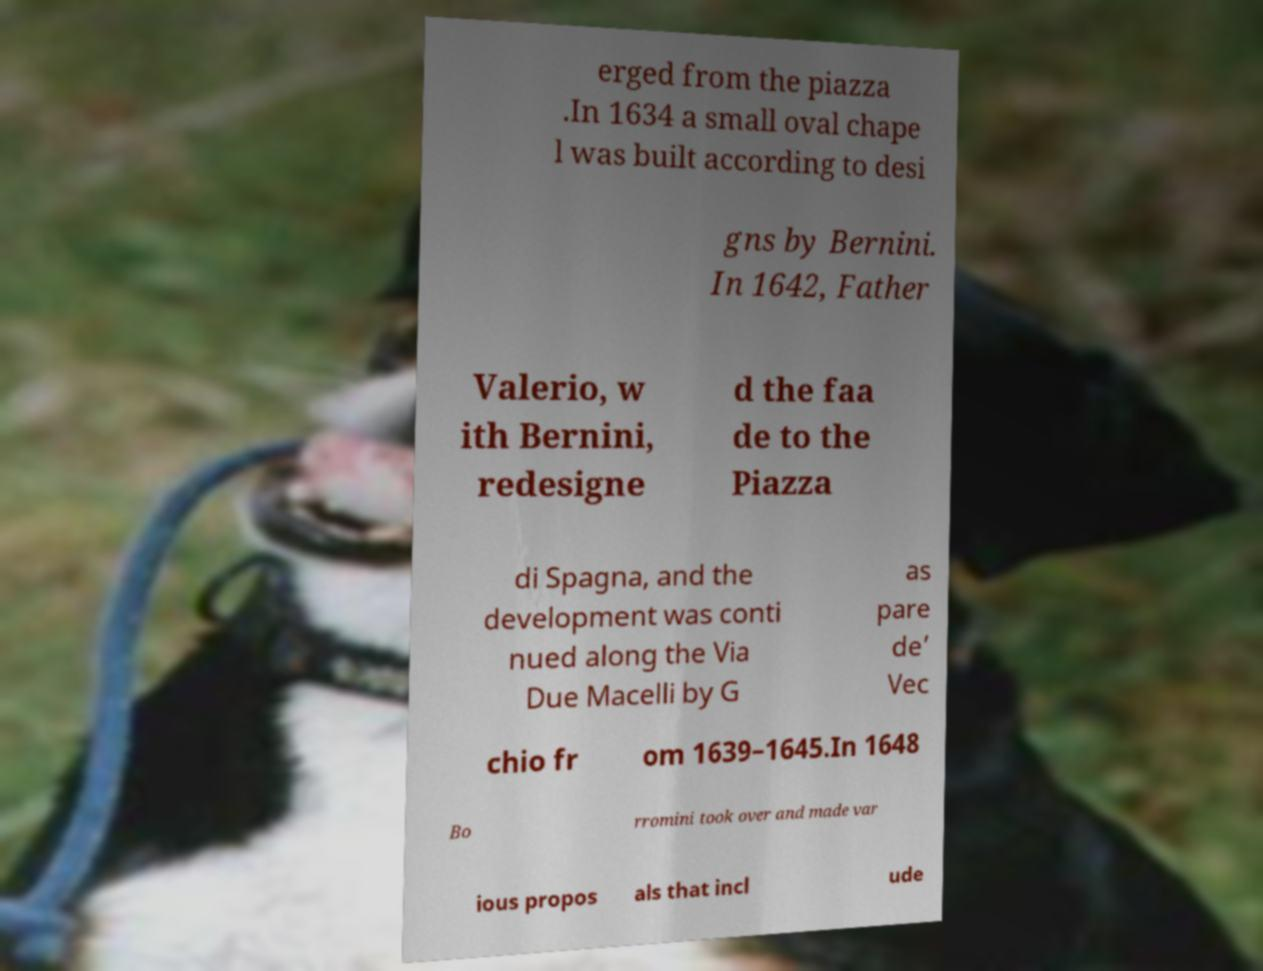Please read and relay the text visible in this image. What does it say? erged from the piazza .In 1634 a small oval chape l was built according to desi gns by Bernini. In 1642, Father Valerio, w ith Bernini, redesigne d the faa de to the Piazza di Spagna, and the development was conti nued along the Via Due Macelli by G as pare de’ Vec chio fr om 1639–1645.In 1648 Bo rromini took over and made var ious propos als that incl ude 